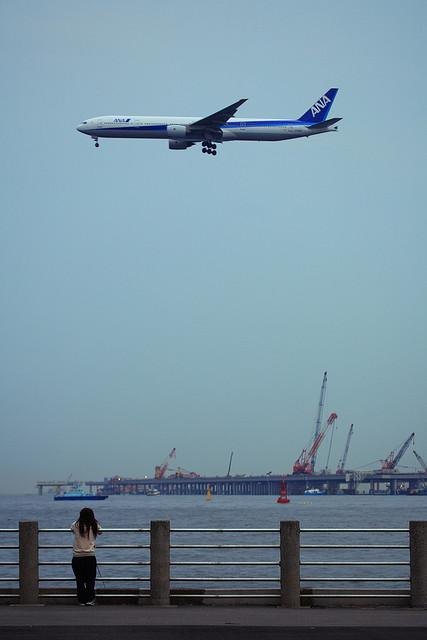From what country does ANA hail from? Please explain your reasoning. japan. Its from japan 